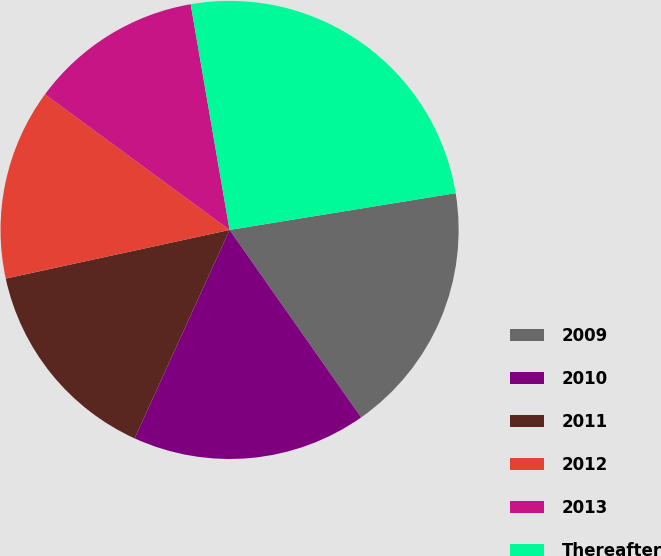Convert chart to OTSL. <chart><loc_0><loc_0><loc_500><loc_500><pie_chart><fcel>2009<fcel>2010<fcel>2011<fcel>2012<fcel>2013<fcel>Thereafter<nl><fcel>17.83%<fcel>16.54%<fcel>14.79%<fcel>13.49%<fcel>12.2%<fcel>25.15%<nl></chart> 